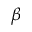<formula> <loc_0><loc_0><loc_500><loc_500>\beta</formula> 